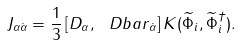Convert formula to latex. <formula><loc_0><loc_0><loc_500><loc_500>J _ { \alpha \dot { \alpha } } = \frac { 1 } { 3 } \left [ D _ { \alpha } , { \ D b a r } _ { \dot { \alpha } } \right ] K ( \widetilde { \Phi } _ { i } , \widetilde { \Phi } _ { i } ^ { \dagger } ) .</formula> 